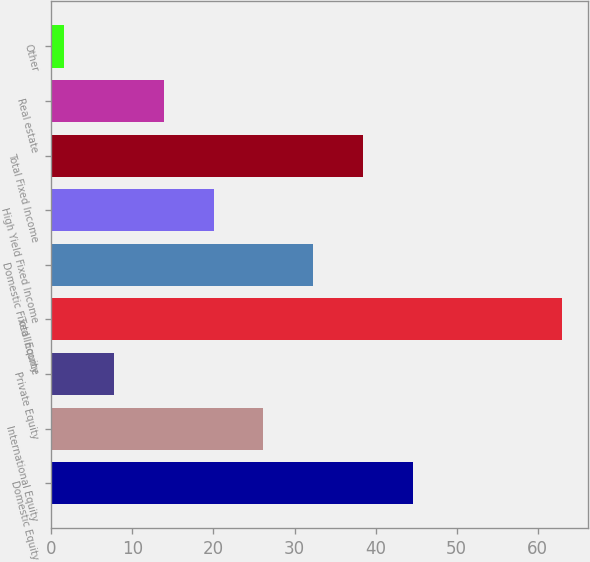Convert chart. <chart><loc_0><loc_0><loc_500><loc_500><bar_chart><fcel>Domestic Equity<fcel>International Equity<fcel>Private Equity<fcel>Total Equity<fcel>Domestic Fixed Income<fcel>High Yield Fixed Income<fcel>Total Fixed Income<fcel>Real estate<fcel>Other<nl><fcel>44.59<fcel>26.17<fcel>7.75<fcel>63<fcel>32.31<fcel>20.03<fcel>38.45<fcel>13.89<fcel>1.61<nl></chart> 